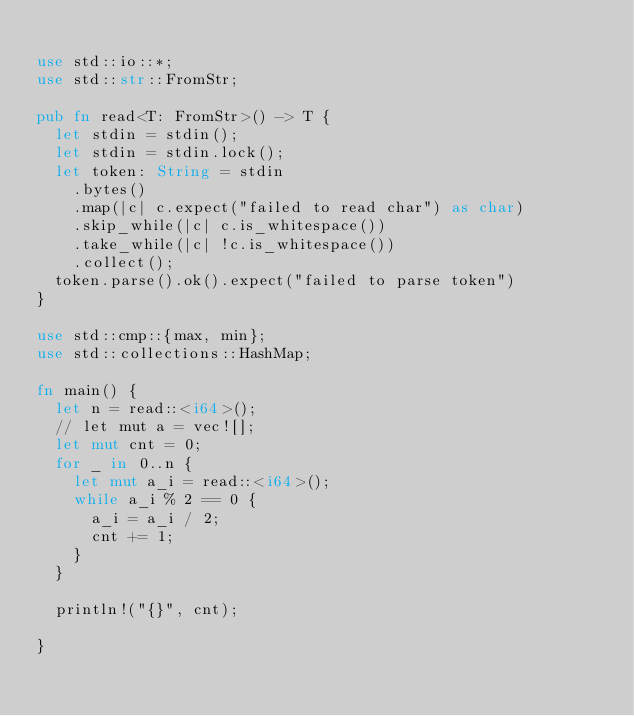<code> <loc_0><loc_0><loc_500><loc_500><_Rust_>
use std::io::*;
use std::str::FromStr;

pub fn read<T: FromStr>() -> T {
  let stdin = stdin();
  let stdin = stdin.lock();
  let token: String = stdin
    .bytes()
    .map(|c| c.expect("failed to read char") as char)
    .skip_while(|c| c.is_whitespace())
    .take_while(|c| !c.is_whitespace())
    .collect();
  token.parse().ok().expect("failed to parse token")
}

use std::cmp::{max, min};
use std::collections::HashMap;

fn main() {
  let n = read::<i64>();
  // let mut a = vec![];
  let mut cnt = 0;
  for _ in 0..n {
    let mut a_i = read::<i64>();
    while a_i % 2 == 0 {
      a_i = a_i / 2;
      cnt += 1;
    }
  }

  println!("{}", cnt);

}</code> 